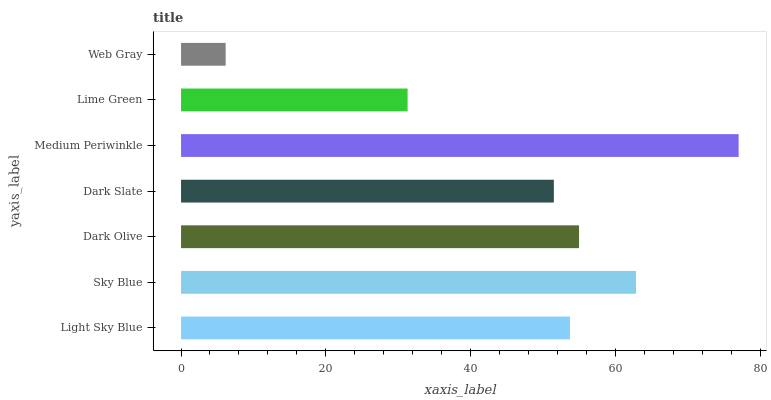Is Web Gray the minimum?
Answer yes or no. Yes. Is Medium Periwinkle the maximum?
Answer yes or no. Yes. Is Sky Blue the minimum?
Answer yes or no. No. Is Sky Blue the maximum?
Answer yes or no. No. Is Sky Blue greater than Light Sky Blue?
Answer yes or no. Yes. Is Light Sky Blue less than Sky Blue?
Answer yes or no. Yes. Is Light Sky Blue greater than Sky Blue?
Answer yes or no. No. Is Sky Blue less than Light Sky Blue?
Answer yes or no. No. Is Light Sky Blue the high median?
Answer yes or no. Yes. Is Light Sky Blue the low median?
Answer yes or no. Yes. Is Medium Periwinkle the high median?
Answer yes or no. No. Is Dark Slate the low median?
Answer yes or no. No. 